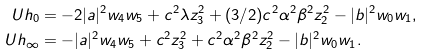Convert formula to latex. <formula><loc_0><loc_0><loc_500><loc_500>U h _ { 0 } & = - 2 | a | ^ { 2 } w _ { 4 } w _ { 5 } + { c } ^ { 2 } \lambda z _ { 3 } ^ { 2 } + ( 3 / 2 ) { c } ^ { 2 } \alpha ^ { 2 } \beta ^ { 2 } z _ { 2 } ^ { 2 } - | { b } | ^ { 2 } w _ { 0 } w _ { 1 } , \\ U h _ { \infty } & = - | { a } | ^ { 2 } w _ { 4 } w _ { 5 } + { c } ^ { 2 } z _ { 3 } ^ { 2 } + { c } ^ { 2 } \alpha ^ { 2 } \beta ^ { 2 } z _ { 2 } ^ { 2 } - | { b } | ^ { 2 } w _ { 0 } w _ { 1 } .</formula> 